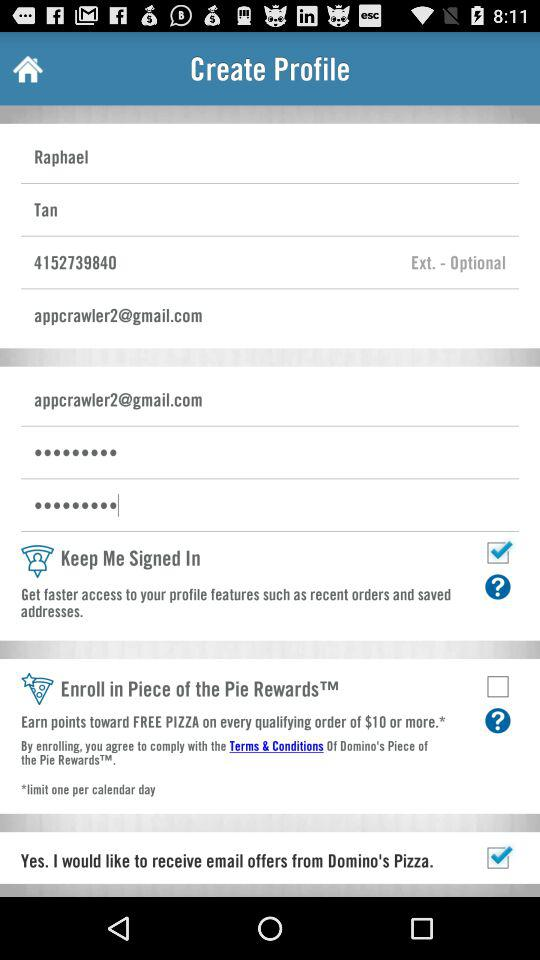What's the user name? The user name is Raphael Tan. 